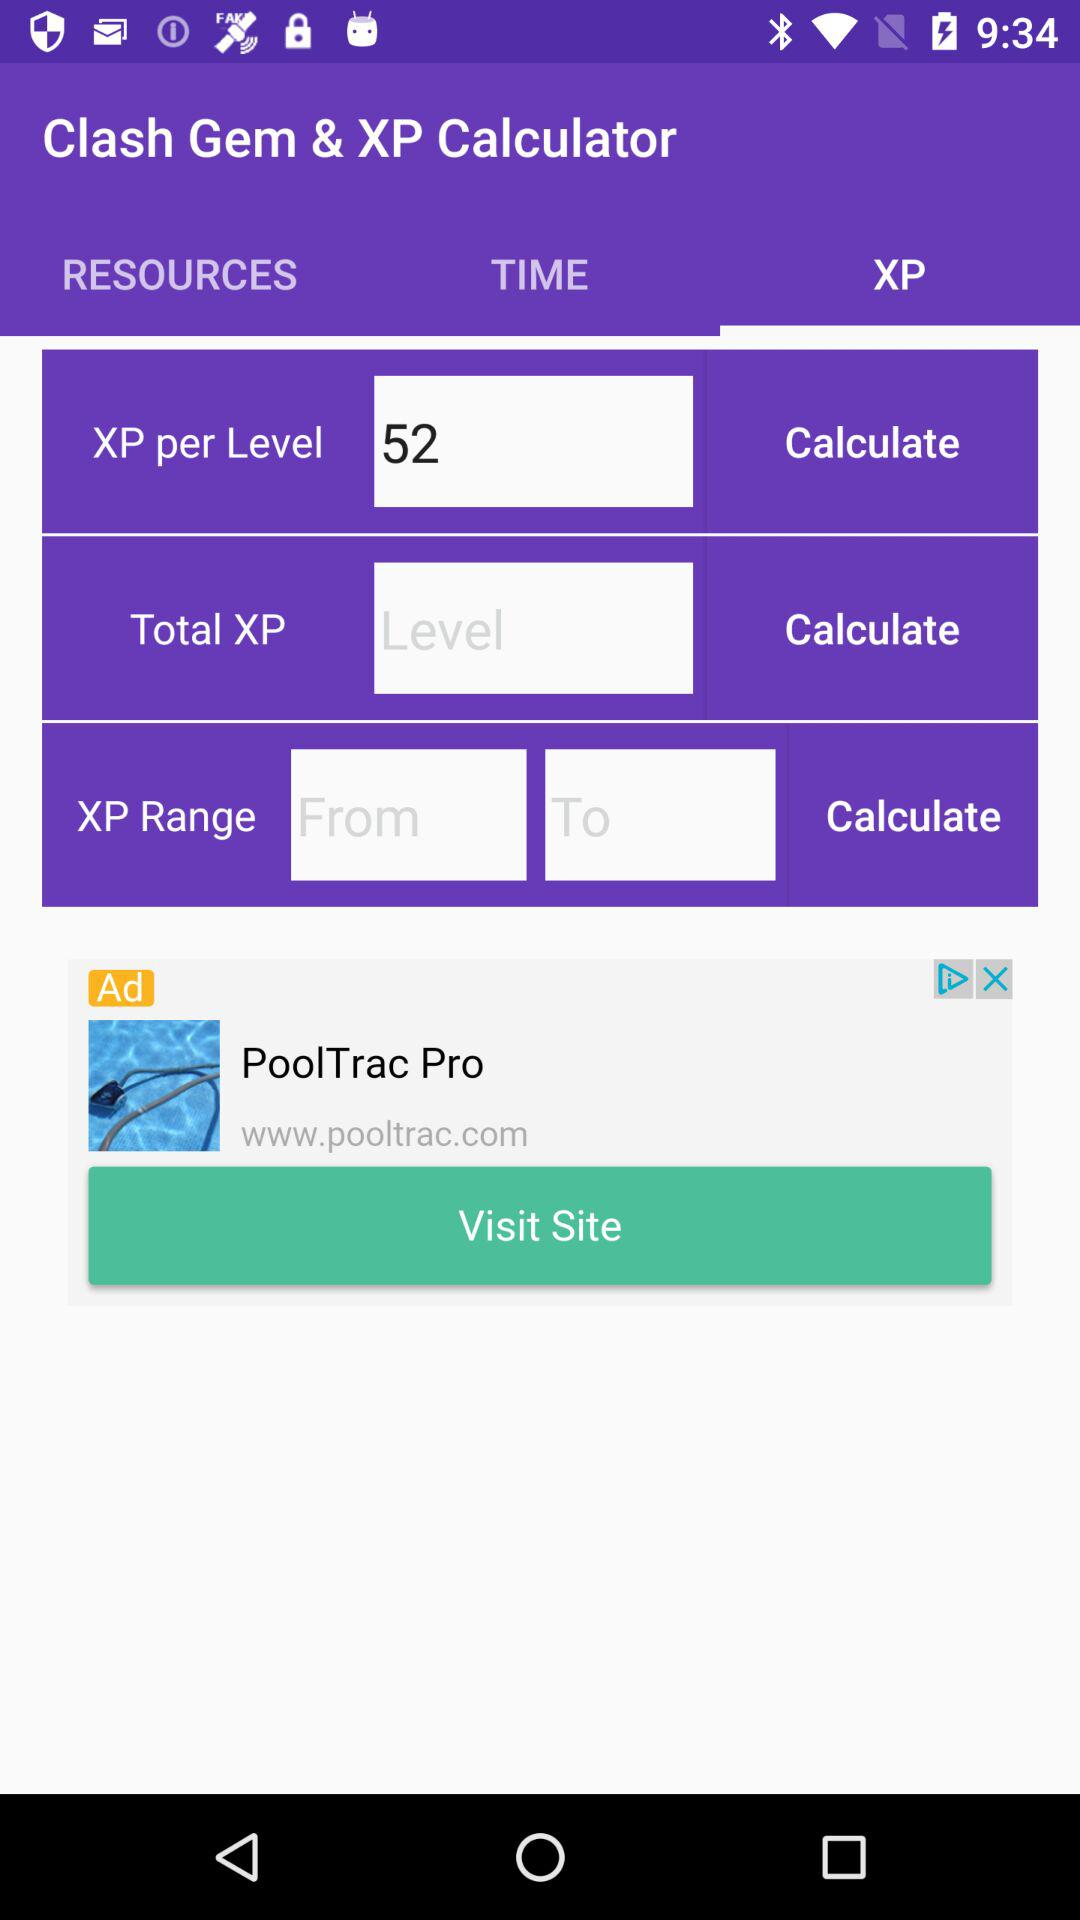What is the value of XP per level? The value of XP per level is 52. 